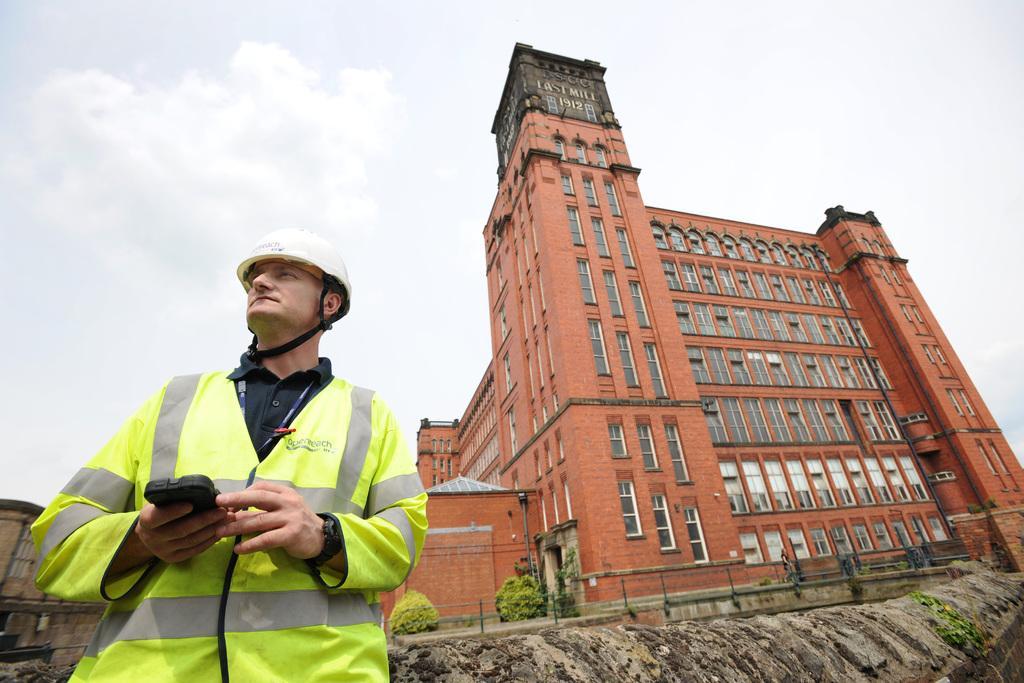In one or two sentences, can you explain what this image depicts? In the foreground I can see a person is standing and holding a camera in hand. In the background I can see a fence, plants, buildings and windows. On the top I can see the sky. This image is taken during a day. 